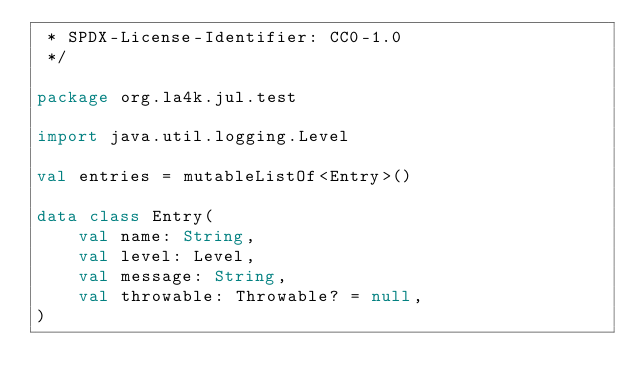Convert code to text. <code><loc_0><loc_0><loc_500><loc_500><_Kotlin_> * SPDX-License-Identifier: CC0-1.0
 */

package org.la4k.jul.test

import java.util.logging.Level

val entries = mutableListOf<Entry>()

data class Entry(
    val name: String,
    val level: Level,
    val message: String,
    val throwable: Throwable? = null,
)
</code> 